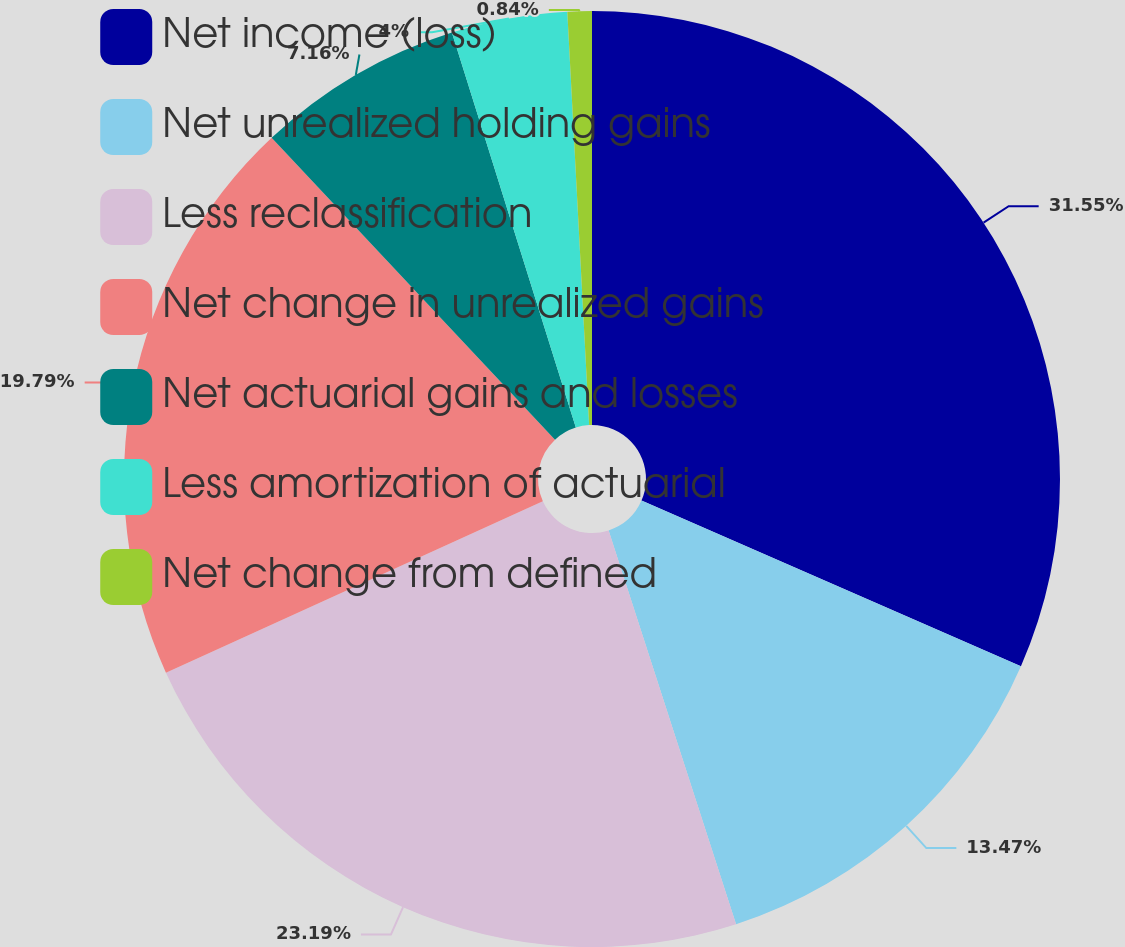<chart> <loc_0><loc_0><loc_500><loc_500><pie_chart><fcel>Net income (loss)<fcel>Net unrealized holding gains<fcel>Less reclassification<fcel>Net change in unrealized gains<fcel>Net actuarial gains and losses<fcel>Less amortization of actuarial<fcel>Net change from defined<nl><fcel>31.55%<fcel>13.47%<fcel>23.19%<fcel>19.79%<fcel>7.16%<fcel>4.0%<fcel>0.84%<nl></chart> 